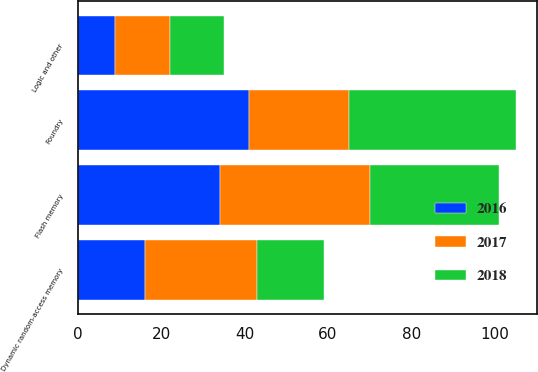<chart> <loc_0><loc_0><loc_500><loc_500><stacked_bar_chart><ecel><fcel>Foundry<fcel>Dynamic random-access memory<fcel>Flash memory<fcel>Logic and other<nl><fcel>2017<fcel>24<fcel>27<fcel>36<fcel>13<nl><fcel>2016<fcel>41<fcel>16<fcel>34<fcel>9<nl><fcel>2018<fcel>40<fcel>16<fcel>31<fcel>13<nl></chart> 